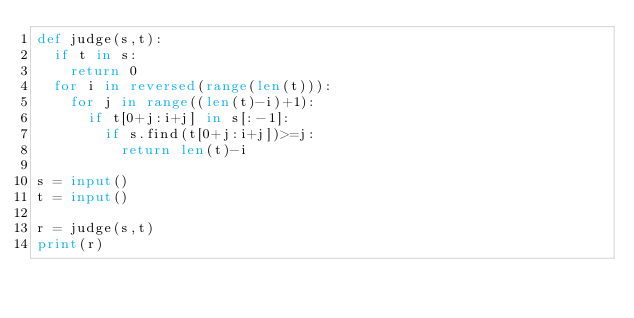Convert code to text. <code><loc_0><loc_0><loc_500><loc_500><_Python_>def judge(s,t):
  if t in s:
    return 0
  for i in reversed(range(len(t))):
    for j in range((len(t)-i)+1):
      if t[0+j:i+j] in s[:-1]:
        if s.find(t[0+j:i+j])>=j:
          return len(t)-i

s = input()
t = input()

r = judge(s,t)
print(r)</code> 